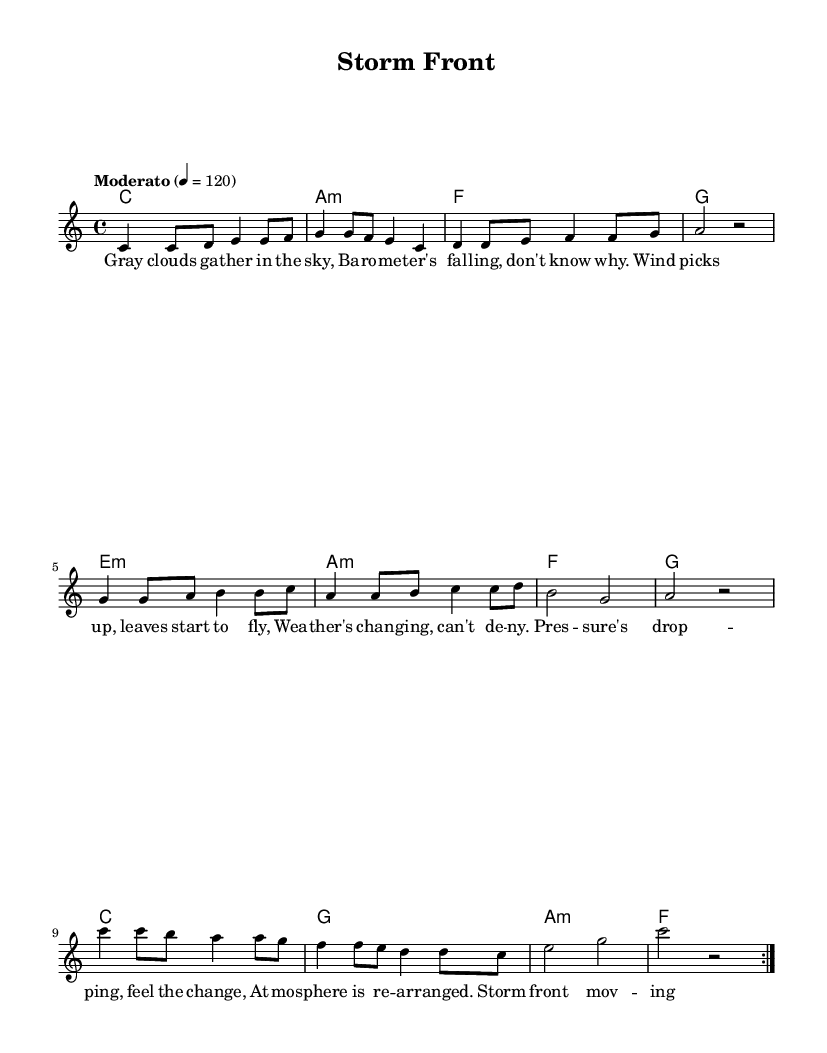What is the key signature of this music? The key signature is indicated at the beginning of the score. It is C major, which has no sharps or flats.
Answer: C major What is the time signature of this music? The time signature is displayed at the beginning of the piece. It is in 4/4 time, meaning there are four beats per measure and a quarter note receives one beat.
Answer: 4/4 What is the tempo marking of this piece? The tempo marking is found at the top of the score. It states "Moderato" with a metronome marking of 120 beats per minute, indicating a moderate pace.
Answer: Moderato, 120 How many times does the melody repeat? The repeat indication is shown in the melody section with a "repeat volta 2," indicating that the melody is played two times.
Answer: 2 What is the name of this song? The title of the piece is found at the top of the score under "title"; it is called "Storm Front."
Answer: Storm Front What is the first chord used in the harmony? The first chord can be seen in the harmonies section at the beginning. It is a C major chord.
Answer: C What type of musical form is used in this piece? This piece follows a simple verse structure, as indicated by the presence of lyrics matched to the melody. The lyrics are structured in a way that they fit the musical phrases.
Answer: Verse 